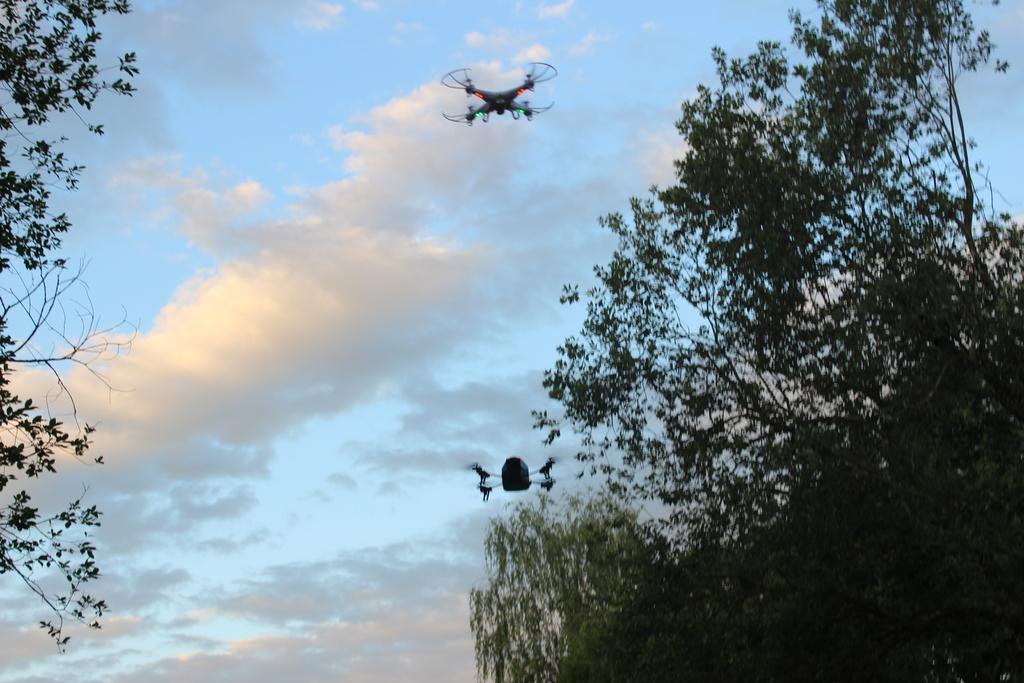How would you summarize this image in a sentence or two? In this image I can see the trees in green color and I can also see two drones, background the sky is in blue and white color. 